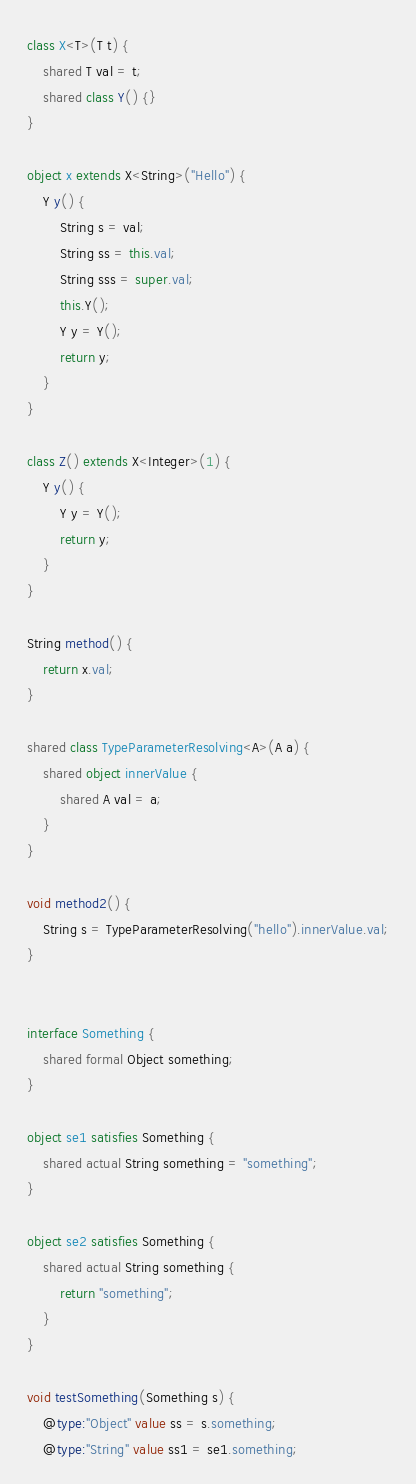<code> <loc_0><loc_0><loc_500><loc_500><_Ceylon_>class X<T>(T t) {
    shared T val = t;
    shared class Y() {}
}

object x extends X<String>("Hello") {
    Y y() {
        String s = val;
        String ss = this.val;
        String sss = super.val;
        this.Y();
        Y y = Y();
        return y;
    }
}

class Z() extends X<Integer>(1) {
    Y y() {
        Y y = Y();
        return y;
    }
}

String method() {
    return x.val;
}

shared class TypeParameterResolving<A>(A a) {
    shared object innerValue {
        shared A val = a;
    }
}

void method2() {
    String s = TypeParameterResolving("hello").innerValue.val;
}


interface Something {
    shared formal Object something;
}

object se1 satisfies Something {
    shared actual String something = "something";
}

object se2 satisfies Something {
    shared actual String something { 
        return "something"; 
    }
}

void testSomething(Something s) {
    @type:"Object" value ss = s.something;
    @type:"String" value ss1 = se1.something;</code> 